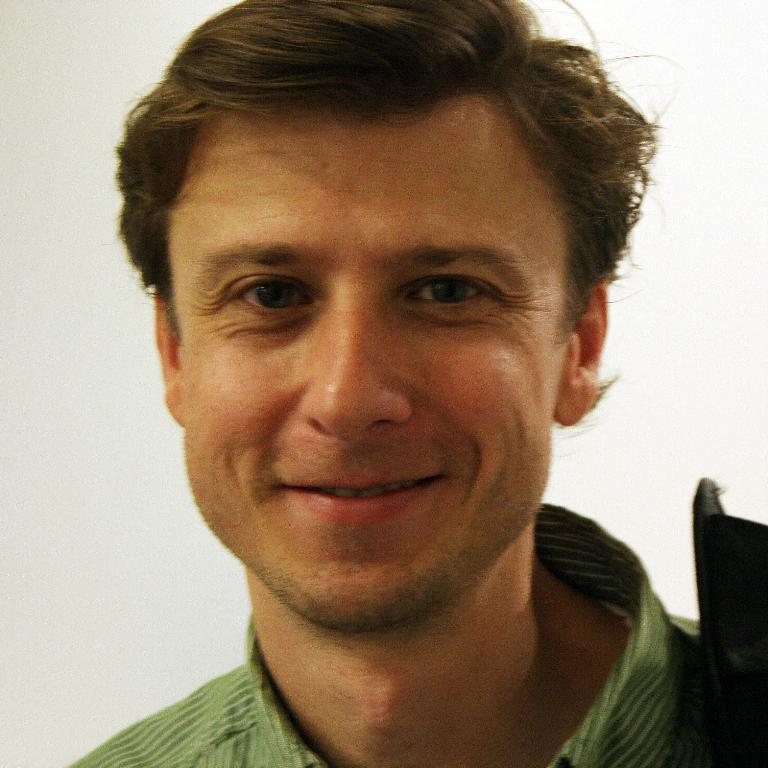Who or what is the main subject of the image? There is a person in the image. What is the person wearing? The person is wearing a green shirt. What is the person's facial expression in the image? The person is smiling. What color is the background of the image? The background of the image is white in color. What type of plant is the person holding in the image? There is no plant present in the image; the person is not holding anything. 